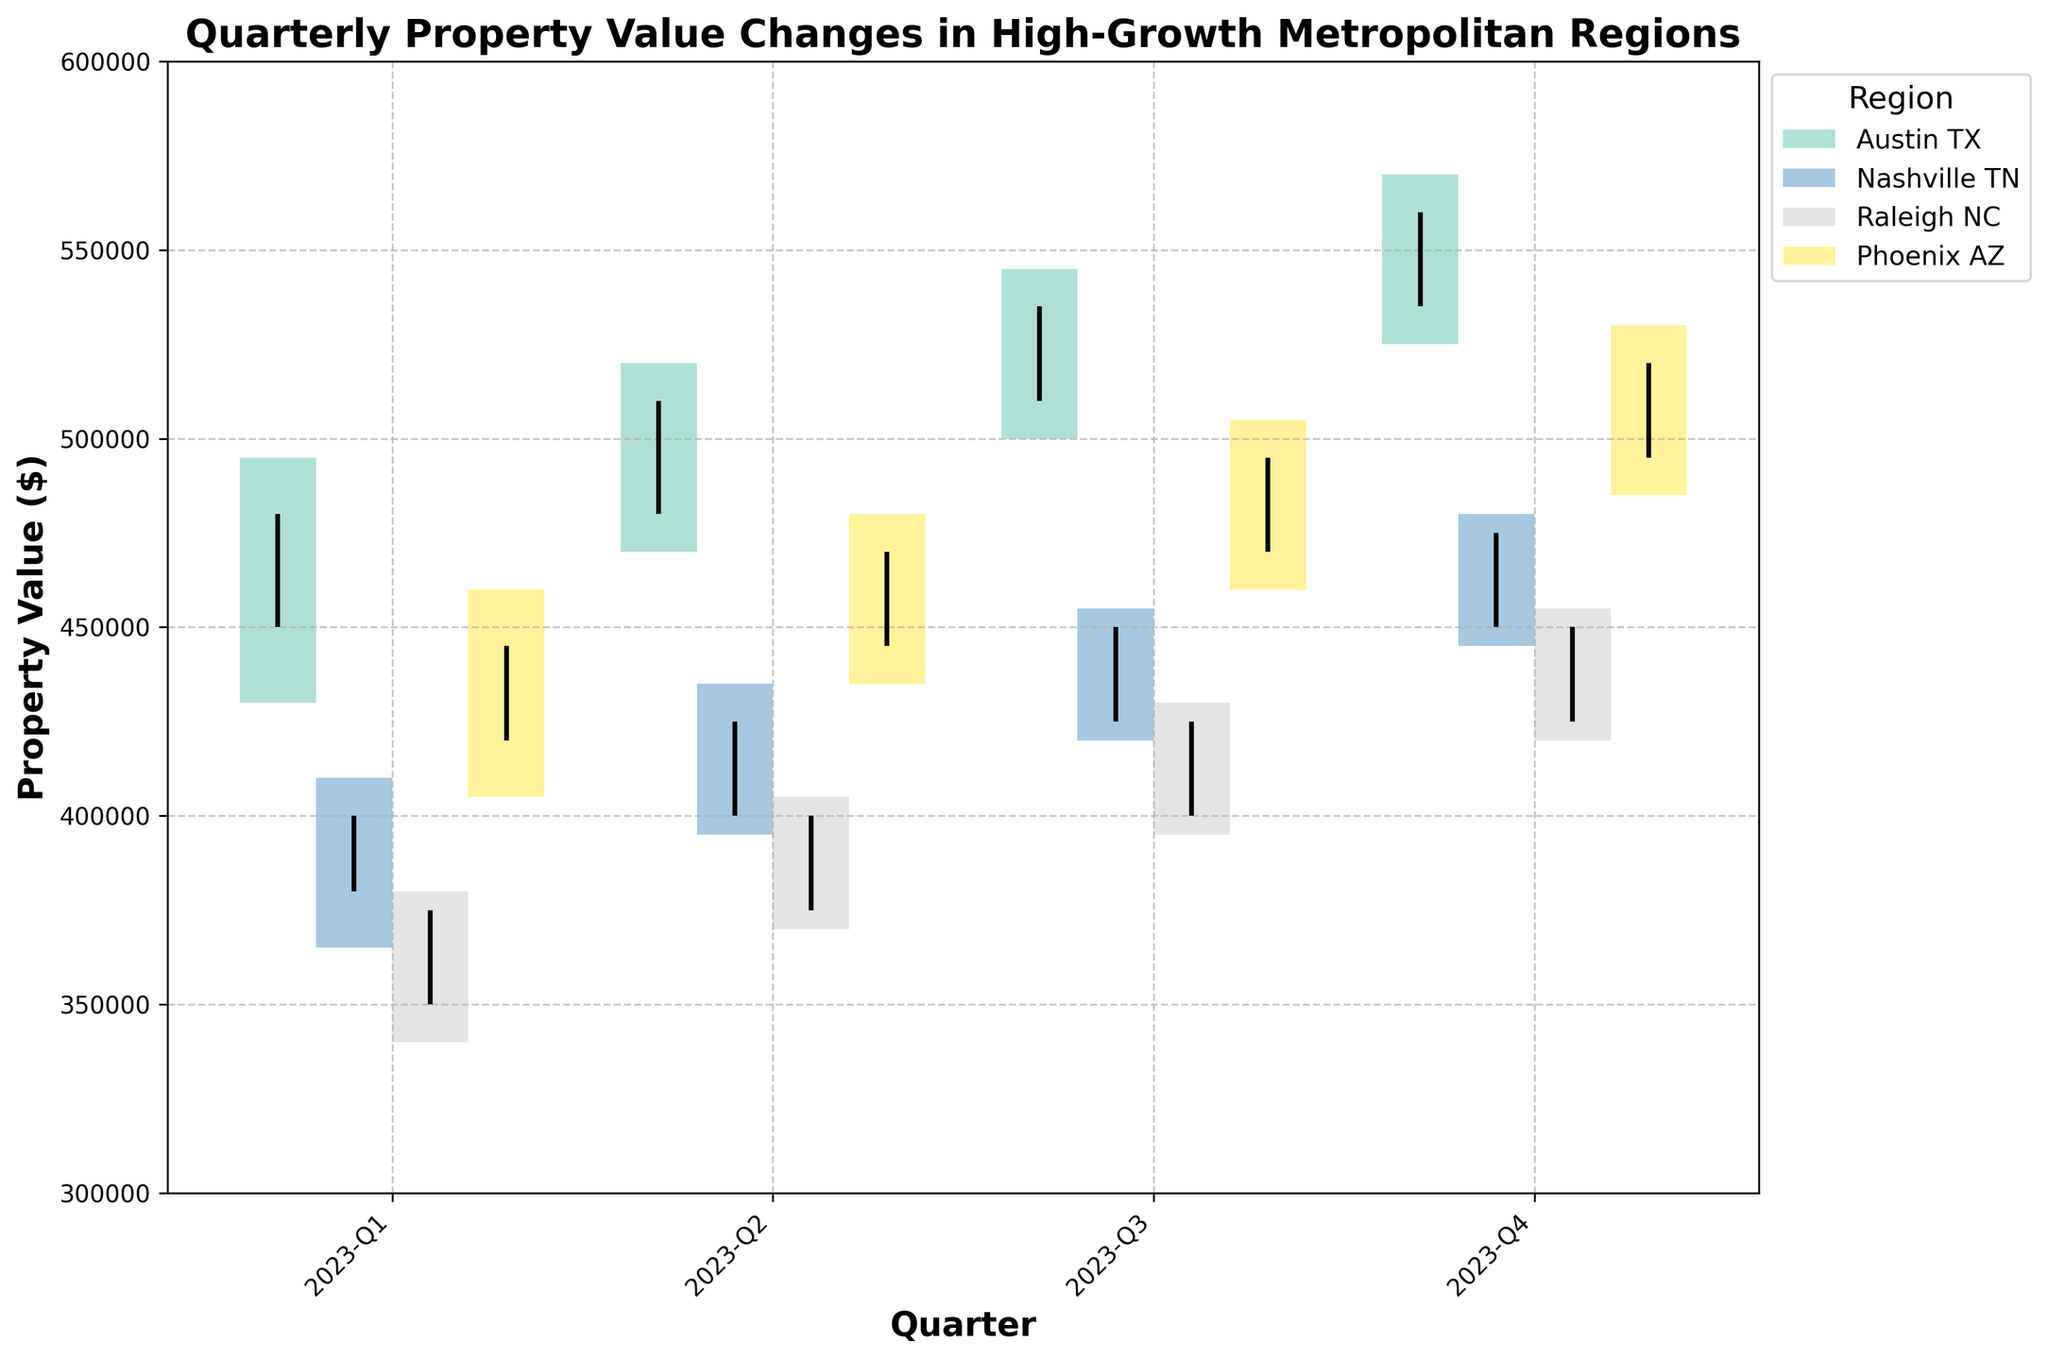What is the title of the figure? The title of the figure is displayed at the top, providing an overall description of the chart. It reads "Quarterly Property Value Changes in High-Growth Metropolitan Regions".
Answer: Quarterly Property Value Changes in High-Growth Metropolitan Regions What is the Y-axis label? The Y-axis label, which is situated on the left vertical axis of the chart, provides information about what the vertical axis represents. It is labeled "Property Value ($)".
Answer: Property Value ($) How many regions are being analyzed in the figure? By observing the legend on the right side of the chart, we can see four distinct regions represented by different colored bars. These regions are Austin TX, Nashville TN, Raleigh NC, and Phoenix AZ.
Answer: 4 In which quarter did Austin TX experience the highest closing property value? By examining the closing values (indicated by the top endpoint of the vertical lines within the bars for each quarter), it is apparent that Austin TX had its highest closing property value in Q4, with a value of $560,000.
Answer: Q4 Which region shows the least increase in property value from Q1 to Q4? By comparing the closing values from Q1 to Q4 for each region, Nashville TN shows the smallest increase, moving from $400,000 in Q1 to $475,000 in Q4, an increase of $75,000.
Answer: Nashville TN What is the range of property values for Phoenix AZ in Q3? To find the range, subtract the lowest property value from the highest property value in Q3 for Phoenix AZ. The high is $505,000 and the low is $460,000, giving a range of $505,000 - $460,000 = $45,000.
Answer: $45,000 Which region had the highest opening property value in Q2? Checking the opening values for Q2, Austin TX had the highest, starting at $480,000.
Answer: Austin TX Compare the property value growth from Q3 to Q4 between Raleigh NC and Phoenix AZ. Which region grew more, and by how much? Raleigh NC's closing value increased from $425,000 to $450,000, a growth of $25,000. Phoenix AZ's closing value increased from $495,000 to $520,000, a growth of $25,000. Since both regions had the same growth of $25,000, there is no difference in their growth.
Answer: Both regions grew the same, $25,000 What was the closing property value for Nashville TN in Q2? The closing property value for Nashville TN in Q2 can be directly read from the figure where the vertical line ends for Q2, which is $425,000.
Answer: $425,000 